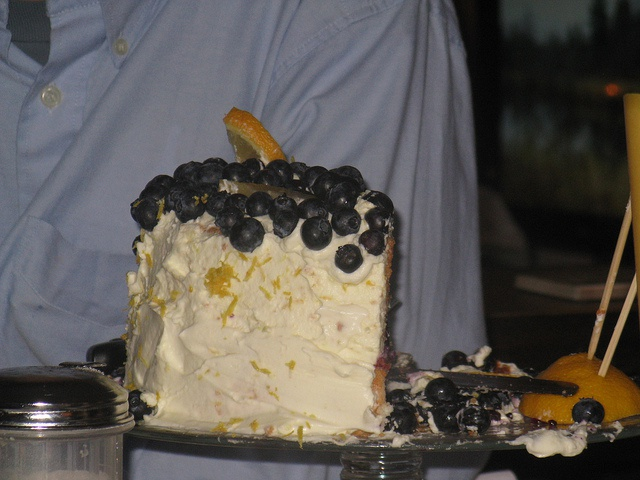Describe the objects in this image and their specific colors. I can see people in gray and black tones, cake in gray, tan, and black tones, bottle in gray and black tones, orange in gray, olive, maroon, and black tones, and knife in gray, black, and maroon tones in this image. 